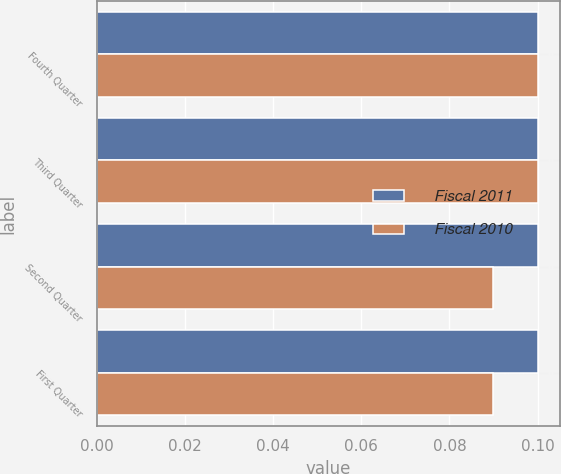Convert chart to OTSL. <chart><loc_0><loc_0><loc_500><loc_500><stacked_bar_chart><ecel><fcel>Fourth Quarter<fcel>Third Quarter<fcel>Second Quarter<fcel>First Quarter<nl><fcel>Fiscal 2011<fcel>0.1<fcel>0.1<fcel>0.1<fcel>0.1<nl><fcel>Fiscal 2010<fcel>0.1<fcel>0.1<fcel>0.09<fcel>0.09<nl></chart> 